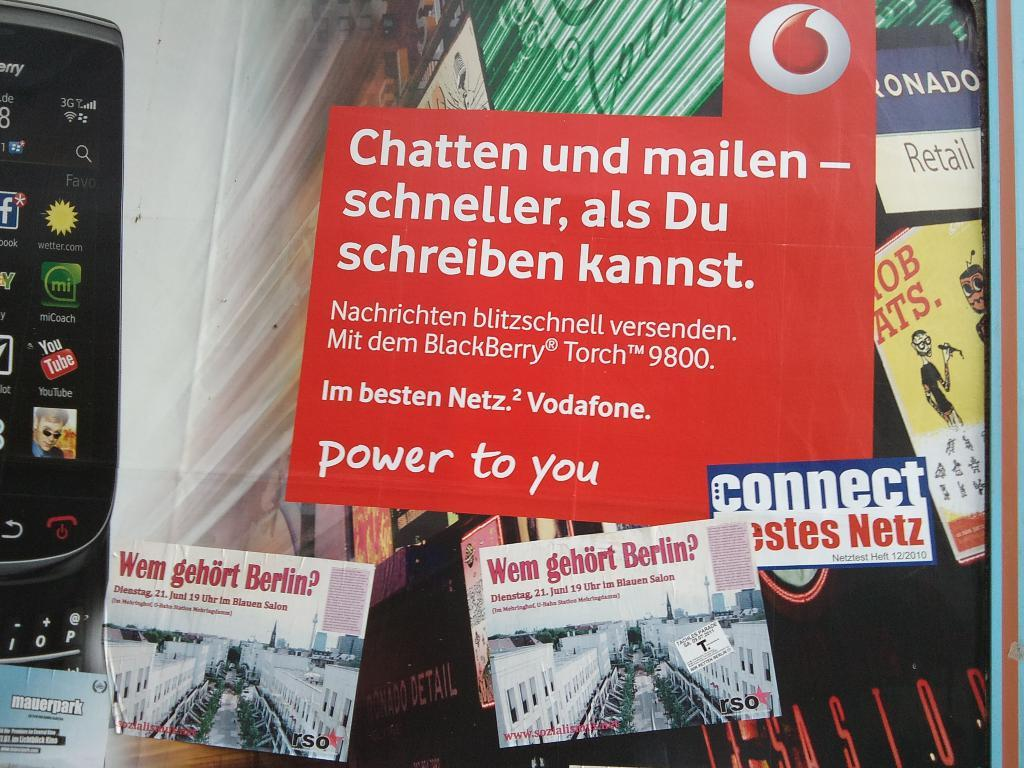Provide a one-sentence caption for the provided image. A collection of postcards with one titled Chatten und mailen. 